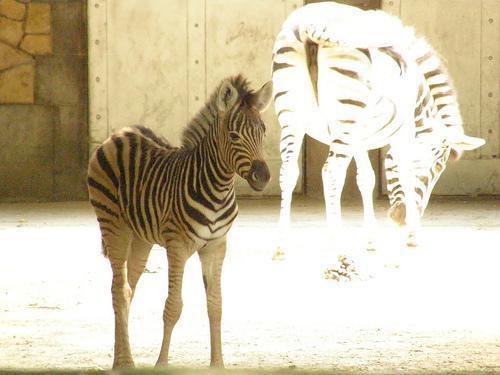How many zebras are there?
Give a very brief answer. 2. 